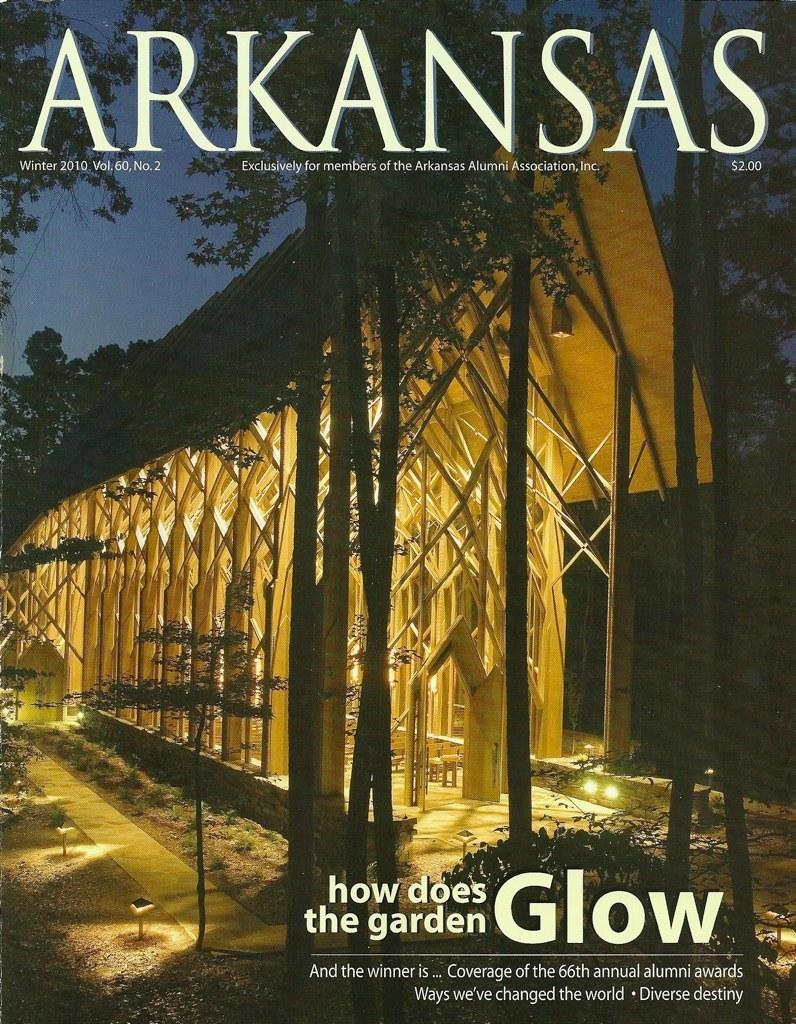Describe this image in one or two sentences. In this image there is a cover page of a magazine. In this image there is a garden built on wooden sticks and lights. At the top and bottom of the image there is some text. 